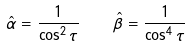<formula> <loc_0><loc_0><loc_500><loc_500>\hat { \alpha } = \frac { 1 } { \cos ^ { 2 } \tau } \quad \hat { \beta } = \frac { 1 } { \cos ^ { 4 } \tau }</formula> 